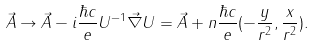<formula> <loc_0><loc_0><loc_500><loc_500>\vec { A } \rightarrow \vec { A } - i \frac { \hbar { c } } { e } U ^ { - 1 } \vec { \nabla } U = \vec { A } + n \frac { \hbar { c } } { e } ( - \frac { y } { r ^ { 2 } } , \frac { x } { r ^ { 2 } } ) .</formula> 